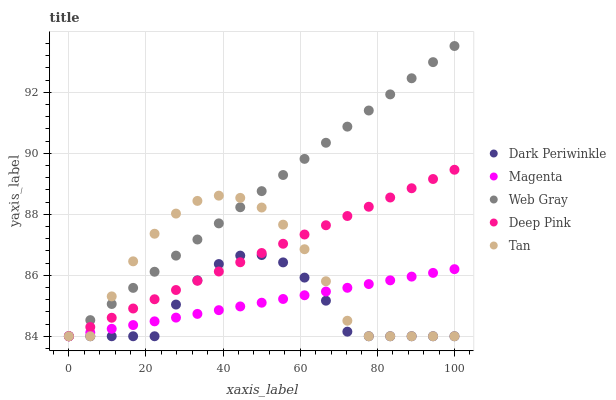Does Dark Periwinkle have the minimum area under the curve?
Answer yes or no. Yes. Does Web Gray have the maximum area under the curve?
Answer yes or no. Yes. Does Tan have the minimum area under the curve?
Answer yes or no. No. Does Tan have the maximum area under the curve?
Answer yes or no. No. Is Magenta the smoothest?
Answer yes or no. Yes. Is Tan the roughest?
Answer yes or no. Yes. Is Web Gray the smoothest?
Answer yes or no. No. Is Web Gray the roughest?
Answer yes or no. No. Does Magenta have the lowest value?
Answer yes or no. Yes. Does Web Gray have the highest value?
Answer yes or no. Yes. Does Tan have the highest value?
Answer yes or no. No. Does Dark Periwinkle intersect Tan?
Answer yes or no. Yes. Is Dark Periwinkle less than Tan?
Answer yes or no. No. Is Dark Periwinkle greater than Tan?
Answer yes or no. No. 